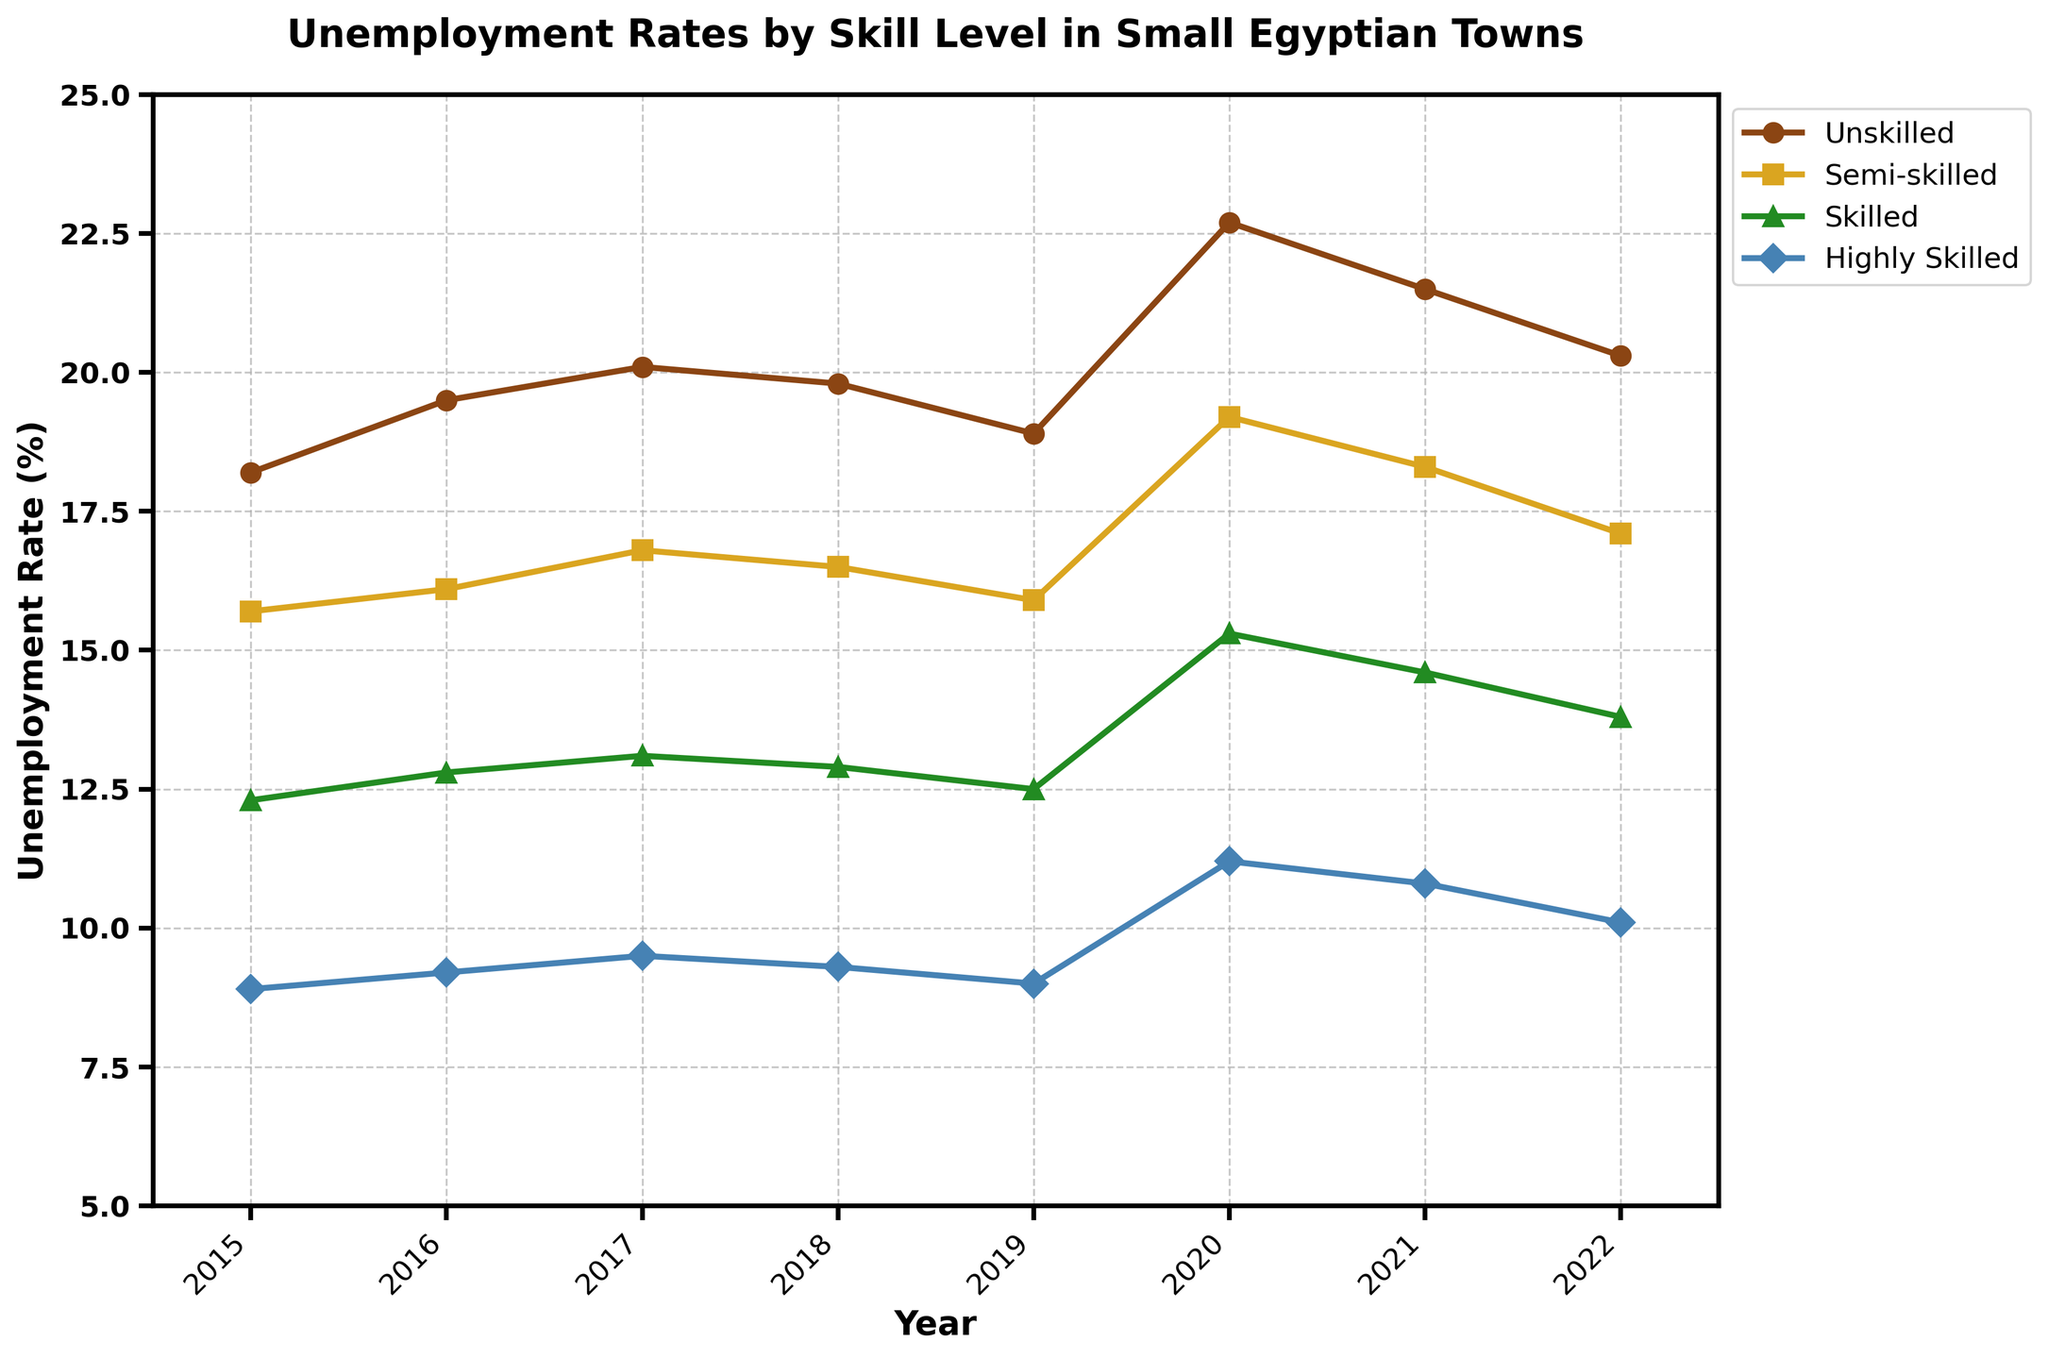What is the unemployment rate for unskilled labor in 2020? The line for unskilled labor shows the highest point in 2020. From the figure, the unemployment rate for unskilled labor in 2020 is at its peak, which is marked on the y-axis.
Answer: 22.7% How did the unemployment rate for semi-skilled labor change from 2015 to 2022? To find the change in unemployment rates for semi-skilled labor, compare the values for 2015 and 2022 on the y-axis. The rate started at 15.7% in 2015 and rose to 17.1% in 2022.
Answer: Increased by 1.4% Which skill group had the lowest unemployment rate in 2017? By comparing the lines and their corresponding y-values for the year 2017, the line representing Highly Skilled labor has the lowest position on the y-axis.
Answer: Highly Skilled What is the average unemployment rate for skilled labor over the given years? Calculate the average by summing the unemployment rates for Skilled labor from 2015 to 2022 and dividing by the number of years (8). (12.3 + 12.8 + 13.1 + 12.9 + 12.5 + 15.3 + 14.6 + 13.8) / 8 = 13.41%
Answer: 13.41% In which year did the unemployment rate for highly skilled labor experience the largest increase compared to the previous year? Compare the differences annually from 2015 to 2022 on the Highly Skilled labor line. The bulkiest rise is from 2019 to 2020 (9.0% to 11.2%).
Answer: 2020 Which skill level's unemployment rate had the largest fluctuation throughout the given period? The largest fluctuation is observed by comparing the starting and ending values for each skill level. Unskilled labor ranged from 18.2% in 2015 to 22.7% in 2020 and then decreased to 20.3% in 2022, showing the widest fluctuation.
Answer: Unskilled What is the total increase in the unemployment rate for semi-skilled labor from 2016 to 2017 and from 2020 to 2021? First, calculate the increase from 2016 to 2017: 16.8% - 16.1% = 0.7%. Then, calculate the increase from 2020 to 2021: 18.3% - 19.2% = -0.9%. Sum these increases: 0.7% + (-0.9%) = -0.2%
Answer: -0.2% What is the trend in the unemployment rate for highly skilled labor between 2018 and 2022? Observe the line for Highly Skilled labor from 2018 to 2022. The trend shows a steady decrease, from 9.3% in 2018 to 10.1% in 2022 but reduces gradually after peaking in 2020.
Answer: Decreasing trend 